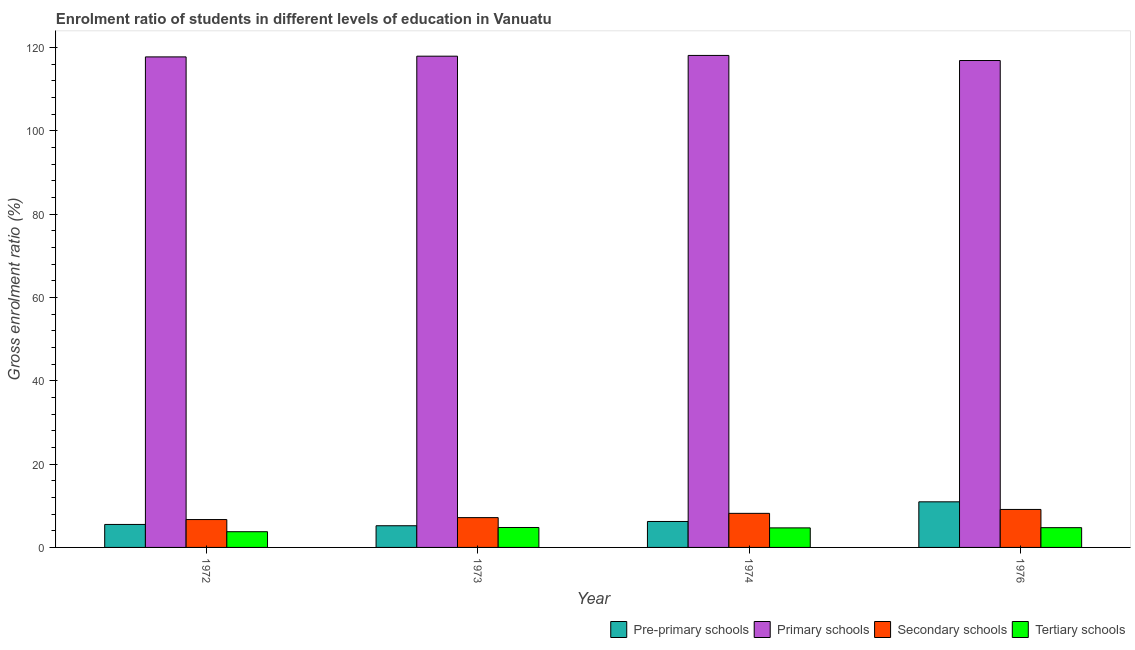How many groups of bars are there?
Give a very brief answer. 4. Are the number of bars per tick equal to the number of legend labels?
Provide a succinct answer. Yes. What is the label of the 3rd group of bars from the left?
Ensure brevity in your answer.  1974. What is the gross enrolment ratio in secondary schools in 1973?
Offer a very short reply. 7.16. Across all years, what is the maximum gross enrolment ratio in pre-primary schools?
Provide a short and direct response. 10.94. Across all years, what is the minimum gross enrolment ratio in primary schools?
Give a very brief answer. 116.85. In which year was the gross enrolment ratio in tertiary schools maximum?
Give a very brief answer. 1973. In which year was the gross enrolment ratio in primary schools minimum?
Your response must be concise. 1976. What is the total gross enrolment ratio in tertiary schools in the graph?
Your answer should be compact. 17.99. What is the difference between the gross enrolment ratio in tertiary schools in 1972 and that in 1974?
Ensure brevity in your answer.  -0.92. What is the difference between the gross enrolment ratio in secondary schools in 1976 and the gross enrolment ratio in primary schools in 1973?
Provide a short and direct response. 1.96. What is the average gross enrolment ratio in secondary schools per year?
Ensure brevity in your answer.  7.78. In the year 1973, what is the difference between the gross enrolment ratio in secondary schools and gross enrolment ratio in pre-primary schools?
Your answer should be compact. 0. What is the ratio of the gross enrolment ratio in primary schools in 1973 to that in 1976?
Give a very brief answer. 1.01. Is the gross enrolment ratio in pre-primary schools in 1972 less than that in 1974?
Your answer should be very brief. Yes. What is the difference between the highest and the second highest gross enrolment ratio in primary schools?
Make the answer very short. 0.18. What is the difference between the highest and the lowest gross enrolment ratio in pre-primary schools?
Your answer should be very brief. 5.74. Is it the case that in every year, the sum of the gross enrolment ratio in secondary schools and gross enrolment ratio in primary schools is greater than the sum of gross enrolment ratio in pre-primary schools and gross enrolment ratio in tertiary schools?
Provide a short and direct response. No. What does the 3rd bar from the left in 1976 represents?
Offer a very short reply. Secondary schools. What does the 2nd bar from the right in 1972 represents?
Your response must be concise. Secondary schools. Are all the bars in the graph horizontal?
Offer a terse response. No. How many years are there in the graph?
Give a very brief answer. 4. What is the difference between two consecutive major ticks on the Y-axis?
Give a very brief answer. 20. Are the values on the major ticks of Y-axis written in scientific E-notation?
Make the answer very short. No. Does the graph contain any zero values?
Provide a succinct answer. No. Does the graph contain grids?
Keep it short and to the point. No. How many legend labels are there?
Keep it short and to the point. 4. What is the title of the graph?
Your answer should be compact. Enrolment ratio of students in different levels of education in Vanuatu. Does "United Kingdom" appear as one of the legend labels in the graph?
Make the answer very short. No. What is the label or title of the Y-axis?
Keep it short and to the point. Gross enrolment ratio (%). What is the Gross enrolment ratio (%) in Pre-primary schools in 1972?
Ensure brevity in your answer.  5.51. What is the Gross enrolment ratio (%) in Primary schools in 1972?
Give a very brief answer. 117.72. What is the Gross enrolment ratio (%) of Secondary schools in 1972?
Make the answer very short. 6.69. What is the Gross enrolment ratio (%) of Tertiary schools in 1972?
Give a very brief answer. 3.77. What is the Gross enrolment ratio (%) in Pre-primary schools in 1973?
Your answer should be very brief. 5.2. What is the Gross enrolment ratio (%) in Primary schools in 1973?
Offer a very short reply. 117.89. What is the Gross enrolment ratio (%) of Secondary schools in 1973?
Offer a terse response. 7.16. What is the Gross enrolment ratio (%) in Tertiary schools in 1973?
Make the answer very short. 4.78. What is the Gross enrolment ratio (%) in Pre-primary schools in 1974?
Your answer should be compact. 6.23. What is the Gross enrolment ratio (%) of Primary schools in 1974?
Offer a terse response. 118.07. What is the Gross enrolment ratio (%) of Secondary schools in 1974?
Keep it short and to the point. 8.18. What is the Gross enrolment ratio (%) in Tertiary schools in 1974?
Ensure brevity in your answer.  4.69. What is the Gross enrolment ratio (%) in Pre-primary schools in 1976?
Your response must be concise. 10.94. What is the Gross enrolment ratio (%) in Primary schools in 1976?
Provide a succinct answer. 116.85. What is the Gross enrolment ratio (%) in Secondary schools in 1976?
Offer a very short reply. 9.12. What is the Gross enrolment ratio (%) in Tertiary schools in 1976?
Make the answer very short. 4.74. Across all years, what is the maximum Gross enrolment ratio (%) of Pre-primary schools?
Give a very brief answer. 10.94. Across all years, what is the maximum Gross enrolment ratio (%) in Primary schools?
Give a very brief answer. 118.07. Across all years, what is the maximum Gross enrolment ratio (%) of Secondary schools?
Offer a very short reply. 9.12. Across all years, what is the maximum Gross enrolment ratio (%) of Tertiary schools?
Your answer should be very brief. 4.78. Across all years, what is the minimum Gross enrolment ratio (%) in Pre-primary schools?
Offer a very short reply. 5.2. Across all years, what is the minimum Gross enrolment ratio (%) of Primary schools?
Keep it short and to the point. 116.85. Across all years, what is the minimum Gross enrolment ratio (%) of Secondary schools?
Keep it short and to the point. 6.69. Across all years, what is the minimum Gross enrolment ratio (%) in Tertiary schools?
Offer a very short reply. 3.77. What is the total Gross enrolment ratio (%) of Pre-primary schools in the graph?
Your response must be concise. 27.89. What is the total Gross enrolment ratio (%) in Primary schools in the graph?
Make the answer very short. 470.54. What is the total Gross enrolment ratio (%) of Secondary schools in the graph?
Offer a very short reply. 31.14. What is the total Gross enrolment ratio (%) in Tertiary schools in the graph?
Provide a succinct answer. 17.99. What is the difference between the Gross enrolment ratio (%) of Pre-primary schools in 1972 and that in 1973?
Make the answer very short. 0.31. What is the difference between the Gross enrolment ratio (%) in Primary schools in 1972 and that in 1973?
Offer a terse response. -0.17. What is the difference between the Gross enrolment ratio (%) in Secondary schools in 1972 and that in 1973?
Ensure brevity in your answer.  -0.47. What is the difference between the Gross enrolment ratio (%) in Tertiary schools in 1972 and that in 1973?
Keep it short and to the point. -1.01. What is the difference between the Gross enrolment ratio (%) of Pre-primary schools in 1972 and that in 1974?
Keep it short and to the point. -0.71. What is the difference between the Gross enrolment ratio (%) in Primary schools in 1972 and that in 1974?
Make the answer very short. -0.35. What is the difference between the Gross enrolment ratio (%) in Secondary schools in 1972 and that in 1974?
Your answer should be very brief. -1.49. What is the difference between the Gross enrolment ratio (%) in Tertiary schools in 1972 and that in 1974?
Your answer should be compact. -0.92. What is the difference between the Gross enrolment ratio (%) of Pre-primary schools in 1972 and that in 1976?
Your answer should be very brief. -5.43. What is the difference between the Gross enrolment ratio (%) in Primary schools in 1972 and that in 1976?
Offer a very short reply. 0.87. What is the difference between the Gross enrolment ratio (%) of Secondary schools in 1972 and that in 1976?
Ensure brevity in your answer.  -2.43. What is the difference between the Gross enrolment ratio (%) of Tertiary schools in 1972 and that in 1976?
Make the answer very short. -0.97. What is the difference between the Gross enrolment ratio (%) of Pre-primary schools in 1973 and that in 1974?
Make the answer very short. -1.03. What is the difference between the Gross enrolment ratio (%) of Primary schools in 1973 and that in 1974?
Give a very brief answer. -0.18. What is the difference between the Gross enrolment ratio (%) of Secondary schools in 1973 and that in 1974?
Offer a very short reply. -1.02. What is the difference between the Gross enrolment ratio (%) of Tertiary schools in 1973 and that in 1974?
Provide a short and direct response. 0.09. What is the difference between the Gross enrolment ratio (%) in Pre-primary schools in 1973 and that in 1976?
Make the answer very short. -5.74. What is the difference between the Gross enrolment ratio (%) in Primary schools in 1973 and that in 1976?
Give a very brief answer. 1.04. What is the difference between the Gross enrolment ratio (%) in Secondary schools in 1973 and that in 1976?
Provide a short and direct response. -1.96. What is the difference between the Gross enrolment ratio (%) in Tertiary schools in 1973 and that in 1976?
Your answer should be compact. 0.04. What is the difference between the Gross enrolment ratio (%) of Pre-primary schools in 1974 and that in 1976?
Keep it short and to the point. -4.72. What is the difference between the Gross enrolment ratio (%) in Primary schools in 1974 and that in 1976?
Offer a very short reply. 1.22. What is the difference between the Gross enrolment ratio (%) in Secondary schools in 1974 and that in 1976?
Offer a very short reply. -0.94. What is the difference between the Gross enrolment ratio (%) of Tertiary schools in 1974 and that in 1976?
Your response must be concise. -0.05. What is the difference between the Gross enrolment ratio (%) of Pre-primary schools in 1972 and the Gross enrolment ratio (%) of Primary schools in 1973?
Your response must be concise. -112.38. What is the difference between the Gross enrolment ratio (%) in Pre-primary schools in 1972 and the Gross enrolment ratio (%) in Secondary schools in 1973?
Your answer should be very brief. -1.64. What is the difference between the Gross enrolment ratio (%) of Pre-primary schools in 1972 and the Gross enrolment ratio (%) of Tertiary schools in 1973?
Your response must be concise. 0.73. What is the difference between the Gross enrolment ratio (%) in Primary schools in 1972 and the Gross enrolment ratio (%) in Secondary schools in 1973?
Give a very brief answer. 110.56. What is the difference between the Gross enrolment ratio (%) in Primary schools in 1972 and the Gross enrolment ratio (%) in Tertiary schools in 1973?
Make the answer very short. 112.94. What is the difference between the Gross enrolment ratio (%) in Secondary schools in 1972 and the Gross enrolment ratio (%) in Tertiary schools in 1973?
Your answer should be compact. 1.91. What is the difference between the Gross enrolment ratio (%) in Pre-primary schools in 1972 and the Gross enrolment ratio (%) in Primary schools in 1974?
Ensure brevity in your answer.  -112.56. What is the difference between the Gross enrolment ratio (%) of Pre-primary schools in 1972 and the Gross enrolment ratio (%) of Secondary schools in 1974?
Ensure brevity in your answer.  -2.66. What is the difference between the Gross enrolment ratio (%) of Pre-primary schools in 1972 and the Gross enrolment ratio (%) of Tertiary schools in 1974?
Give a very brief answer. 0.82. What is the difference between the Gross enrolment ratio (%) of Primary schools in 1972 and the Gross enrolment ratio (%) of Secondary schools in 1974?
Provide a short and direct response. 109.54. What is the difference between the Gross enrolment ratio (%) in Primary schools in 1972 and the Gross enrolment ratio (%) in Tertiary schools in 1974?
Your response must be concise. 113.03. What is the difference between the Gross enrolment ratio (%) of Secondary schools in 1972 and the Gross enrolment ratio (%) of Tertiary schools in 1974?
Your response must be concise. 2. What is the difference between the Gross enrolment ratio (%) of Pre-primary schools in 1972 and the Gross enrolment ratio (%) of Primary schools in 1976?
Your answer should be compact. -111.34. What is the difference between the Gross enrolment ratio (%) in Pre-primary schools in 1972 and the Gross enrolment ratio (%) in Secondary schools in 1976?
Provide a succinct answer. -3.6. What is the difference between the Gross enrolment ratio (%) in Pre-primary schools in 1972 and the Gross enrolment ratio (%) in Tertiary schools in 1976?
Your response must be concise. 0.77. What is the difference between the Gross enrolment ratio (%) of Primary schools in 1972 and the Gross enrolment ratio (%) of Secondary schools in 1976?
Offer a very short reply. 108.6. What is the difference between the Gross enrolment ratio (%) of Primary schools in 1972 and the Gross enrolment ratio (%) of Tertiary schools in 1976?
Provide a short and direct response. 112.98. What is the difference between the Gross enrolment ratio (%) of Secondary schools in 1972 and the Gross enrolment ratio (%) of Tertiary schools in 1976?
Offer a very short reply. 1.95. What is the difference between the Gross enrolment ratio (%) of Pre-primary schools in 1973 and the Gross enrolment ratio (%) of Primary schools in 1974?
Make the answer very short. -112.87. What is the difference between the Gross enrolment ratio (%) in Pre-primary schools in 1973 and the Gross enrolment ratio (%) in Secondary schools in 1974?
Make the answer very short. -2.97. What is the difference between the Gross enrolment ratio (%) of Pre-primary schools in 1973 and the Gross enrolment ratio (%) of Tertiary schools in 1974?
Keep it short and to the point. 0.51. What is the difference between the Gross enrolment ratio (%) of Primary schools in 1973 and the Gross enrolment ratio (%) of Secondary schools in 1974?
Offer a terse response. 109.72. What is the difference between the Gross enrolment ratio (%) of Primary schools in 1973 and the Gross enrolment ratio (%) of Tertiary schools in 1974?
Make the answer very short. 113.2. What is the difference between the Gross enrolment ratio (%) of Secondary schools in 1973 and the Gross enrolment ratio (%) of Tertiary schools in 1974?
Provide a succinct answer. 2.46. What is the difference between the Gross enrolment ratio (%) in Pre-primary schools in 1973 and the Gross enrolment ratio (%) in Primary schools in 1976?
Give a very brief answer. -111.65. What is the difference between the Gross enrolment ratio (%) in Pre-primary schools in 1973 and the Gross enrolment ratio (%) in Secondary schools in 1976?
Ensure brevity in your answer.  -3.91. What is the difference between the Gross enrolment ratio (%) in Pre-primary schools in 1973 and the Gross enrolment ratio (%) in Tertiary schools in 1976?
Provide a succinct answer. 0.46. What is the difference between the Gross enrolment ratio (%) of Primary schools in 1973 and the Gross enrolment ratio (%) of Secondary schools in 1976?
Give a very brief answer. 108.78. What is the difference between the Gross enrolment ratio (%) in Primary schools in 1973 and the Gross enrolment ratio (%) in Tertiary schools in 1976?
Offer a terse response. 113.15. What is the difference between the Gross enrolment ratio (%) in Secondary schools in 1973 and the Gross enrolment ratio (%) in Tertiary schools in 1976?
Provide a succinct answer. 2.41. What is the difference between the Gross enrolment ratio (%) of Pre-primary schools in 1974 and the Gross enrolment ratio (%) of Primary schools in 1976?
Offer a terse response. -110.62. What is the difference between the Gross enrolment ratio (%) of Pre-primary schools in 1974 and the Gross enrolment ratio (%) of Secondary schools in 1976?
Your answer should be compact. -2.89. What is the difference between the Gross enrolment ratio (%) of Pre-primary schools in 1974 and the Gross enrolment ratio (%) of Tertiary schools in 1976?
Provide a succinct answer. 1.48. What is the difference between the Gross enrolment ratio (%) of Primary schools in 1974 and the Gross enrolment ratio (%) of Secondary schools in 1976?
Offer a very short reply. 108.96. What is the difference between the Gross enrolment ratio (%) in Primary schools in 1974 and the Gross enrolment ratio (%) in Tertiary schools in 1976?
Provide a short and direct response. 113.33. What is the difference between the Gross enrolment ratio (%) in Secondary schools in 1974 and the Gross enrolment ratio (%) in Tertiary schools in 1976?
Offer a terse response. 3.43. What is the average Gross enrolment ratio (%) of Pre-primary schools per year?
Your answer should be compact. 6.97. What is the average Gross enrolment ratio (%) of Primary schools per year?
Provide a short and direct response. 117.63. What is the average Gross enrolment ratio (%) of Secondary schools per year?
Offer a very short reply. 7.78. What is the average Gross enrolment ratio (%) of Tertiary schools per year?
Offer a terse response. 4.5. In the year 1972, what is the difference between the Gross enrolment ratio (%) of Pre-primary schools and Gross enrolment ratio (%) of Primary schools?
Provide a succinct answer. -112.21. In the year 1972, what is the difference between the Gross enrolment ratio (%) of Pre-primary schools and Gross enrolment ratio (%) of Secondary schools?
Keep it short and to the point. -1.17. In the year 1972, what is the difference between the Gross enrolment ratio (%) in Pre-primary schools and Gross enrolment ratio (%) in Tertiary schools?
Keep it short and to the point. 1.74. In the year 1972, what is the difference between the Gross enrolment ratio (%) of Primary schools and Gross enrolment ratio (%) of Secondary schools?
Offer a terse response. 111.03. In the year 1972, what is the difference between the Gross enrolment ratio (%) in Primary schools and Gross enrolment ratio (%) in Tertiary schools?
Your response must be concise. 113.95. In the year 1972, what is the difference between the Gross enrolment ratio (%) in Secondary schools and Gross enrolment ratio (%) in Tertiary schools?
Give a very brief answer. 2.92. In the year 1973, what is the difference between the Gross enrolment ratio (%) in Pre-primary schools and Gross enrolment ratio (%) in Primary schools?
Your answer should be very brief. -112.69. In the year 1973, what is the difference between the Gross enrolment ratio (%) in Pre-primary schools and Gross enrolment ratio (%) in Secondary schools?
Make the answer very short. -1.95. In the year 1973, what is the difference between the Gross enrolment ratio (%) in Pre-primary schools and Gross enrolment ratio (%) in Tertiary schools?
Give a very brief answer. 0.42. In the year 1973, what is the difference between the Gross enrolment ratio (%) of Primary schools and Gross enrolment ratio (%) of Secondary schools?
Provide a succinct answer. 110.74. In the year 1973, what is the difference between the Gross enrolment ratio (%) of Primary schools and Gross enrolment ratio (%) of Tertiary schools?
Provide a short and direct response. 113.11. In the year 1973, what is the difference between the Gross enrolment ratio (%) of Secondary schools and Gross enrolment ratio (%) of Tertiary schools?
Provide a succinct answer. 2.37. In the year 1974, what is the difference between the Gross enrolment ratio (%) in Pre-primary schools and Gross enrolment ratio (%) in Primary schools?
Offer a very short reply. -111.85. In the year 1974, what is the difference between the Gross enrolment ratio (%) of Pre-primary schools and Gross enrolment ratio (%) of Secondary schools?
Your response must be concise. -1.95. In the year 1974, what is the difference between the Gross enrolment ratio (%) in Pre-primary schools and Gross enrolment ratio (%) in Tertiary schools?
Your answer should be very brief. 1.54. In the year 1974, what is the difference between the Gross enrolment ratio (%) in Primary schools and Gross enrolment ratio (%) in Secondary schools?
Offer a terse response. 109.9. In the year 1974, what is the difference between the Gross enrolment ratio (%) in Primary schools and Gross enrolment ratio (%) in Tertiary schools?
Your answer should be compact. 113.38. In the year 1974, what is the difference between the Gross enrolment ratio (%) in Secondary schools and Gross enrolment ratio (%) in Tertiary schools?
Your answer should be very brief. 3.49. In the year 1976, what is the difference between the Gross enrolment ratio (%) in Pre-primary schools and Gross enrolment ratio (%) in Primary schools?
Make the answer very short. -105.91. In the year 1976, what is the difference between the Gross enrolment ratio (%) of Pre-primary schools and Gross enrolment ratio (%) of Secondary schools?
Provide a succinct answer. 1.83. In the year 1976, what is the difference between the Gross enrolment ratio (%) of Pre-primary schools and Gross enrolment ratio (%) of Tertiary schools?
Your response must be concise. 6.2. In the year 1976, what is the difference between the Gross enrolment ratio (%) of Primary schools and Gross enrolment ratio (%) of Secondary schools?
Your answer should be compact. 107.74. In the year 1976, what is the difference between the Gross enrolment ratio (%) of Primary schools and Gross enrolment ratio (%) of Tertiary schools?
Ensure brevity in your answer.  112.11. In the year 1976, what is the difference between the Gross enrolment ratio (%) in Secondary schools and Gross enrolment ratio (%) in Tertiary schools?
Provide a succinct answer. 4.37. What is the ratio of the Gross enrolment ratio (%) in Pre-primary schools in 1972 to that in 1973?
Offer a terse response. 1.06. What is the ratio of the Gross enrolment ratio (%) in Secondary schools in 1972 to that in 1973?
Your answer should be very brief. 0.93. What is the ratio of the Gross enrolment ratio (%) of Tertiary schools in 1972 to that in 1973?
Keep it short and to the point. 0.79. What is the ratio of the Gross enrolment ratio (%) of Pre-primary schools in 1972 to that in 1974?
Your answer should be compact. 0.89. What is the ratio of the Gross enrolment ratio (%) in Secondary schools in 1972 to that in 1974?
Keep it short and to the point. 0.82. What is the ratio of the Gross enrolment ratio (%) in Tertiary schools in 1972 to that in 1974?
Offer a very short reply. 0.8. What is the ratio of the Gross enrolment ratio (%) in Pre-primary schools in 1972 to that in 1976?
Your response must be concise. 0.5. What is the ratio of the Gross enrolment ratio (%) in Primary schools in 1972 to that in 1976?
Make the answer very short. 1.01. What is the ratio of the Gross enrolment ratio (%) in Secondary schools in 1972 to that in 1976?
Give a very brief answer. 0.73. What is the ratio of the Gross enrolment ratio (%) in Tertiary schools in 1972 to that in 1976?
Your answer should be very brief. 0.8. What is the ratio of the Gross enrolment ratio (%) in Pre-primary schools in 1973 to that in 1974?
Ensure brevity in your answer.  0.84. What is the ratio of the Gross enrolment ratio (%) in Primary schools in 1973 to that in 1974?
Make the answer very short. 1. What is the ratio of the Gross enrolment ratio (%) of Secondary schools in 1973 to that in 1974?
Your answer should be compact. 0.88. What is the ratio of the Gross enrolment ratio (%) of Tertiary schools in 1973 to that in 1974?
Provide a short and direct response. 1.02. What is the ratio of the Gross enrolment ratio (%) in Pre-primary schools in 1973 to that in 1976?
Ensure brevity in your answer.  0.48. What is the ratio of the Gross enrolment ratio (%) of Primary schools in 1973 to that in 1976?
Ensure brevity in your answer.  1.01. What is the ratio of the Gross enrolment ratio (%) in Secondary schools in 1973 to that in 1976?
Your answer should be very brief. 0.78. What is the ratio of the Gross enrolment ratio (%) of Tertiary schools in 1973 to that in 1976?
Your answer should be very brief. 1.01. What is the ratio of the Gross enrolment ratio (%) in Pre-primary schools in 1974 to that in 1976?
Provide a succinct answer. 0.57. What is the ratio of the Gross enrolment ratio (%) of Primary schools in 1974 to that in 1976?
Provide a short and direct response. 1.01. What is the ratio of the Gross enrolment ratio (%) of Secondary schools in 1974 to that in 1976?
Make the answer very short. 0.9. What is the ratio of the Gross enrolment ratio (%) of Tertiary schools in 1974 to that in 1976?
Offer a very short reply. 0.99. What is the difference between the highest and the second highest Gross enrolment ratio (%) of Pre-primary schools?
Your response must be concise. 4.72. What is the difference between the highest and the second highest Gross enrolment ratio (%) of Primary schools?
Offer a terse response. 0.18. What is the difference between the highest and the second highest Gross enrolment ratio (%) in Secondary schools?
Ensure brevity in your answer.  0.94. What is the difference between the highest and the second highest Gross enrolment ratio (%) of Tertiary schools?
Keep it short and to the point. 0.04. What is the difference between the highest and the lowest Gross enrolment ratio (%) of Pre-primary schools?
Offer a terse response. 5.74. What is the difference between the highest and the lowest Gross enrolment ratio (%) of Primary schools?
Your answer should be very brief. 1.22. What is the difference between the highest and the lowest Gross enrolment ratio (%) in Secondary schools?
Keep it short and to the point. 2.43. What is the difference between the highest and the lowest Gross enrolment ratio (%) of Tertiary schools?
Your answer should be very brief. 1.01. 